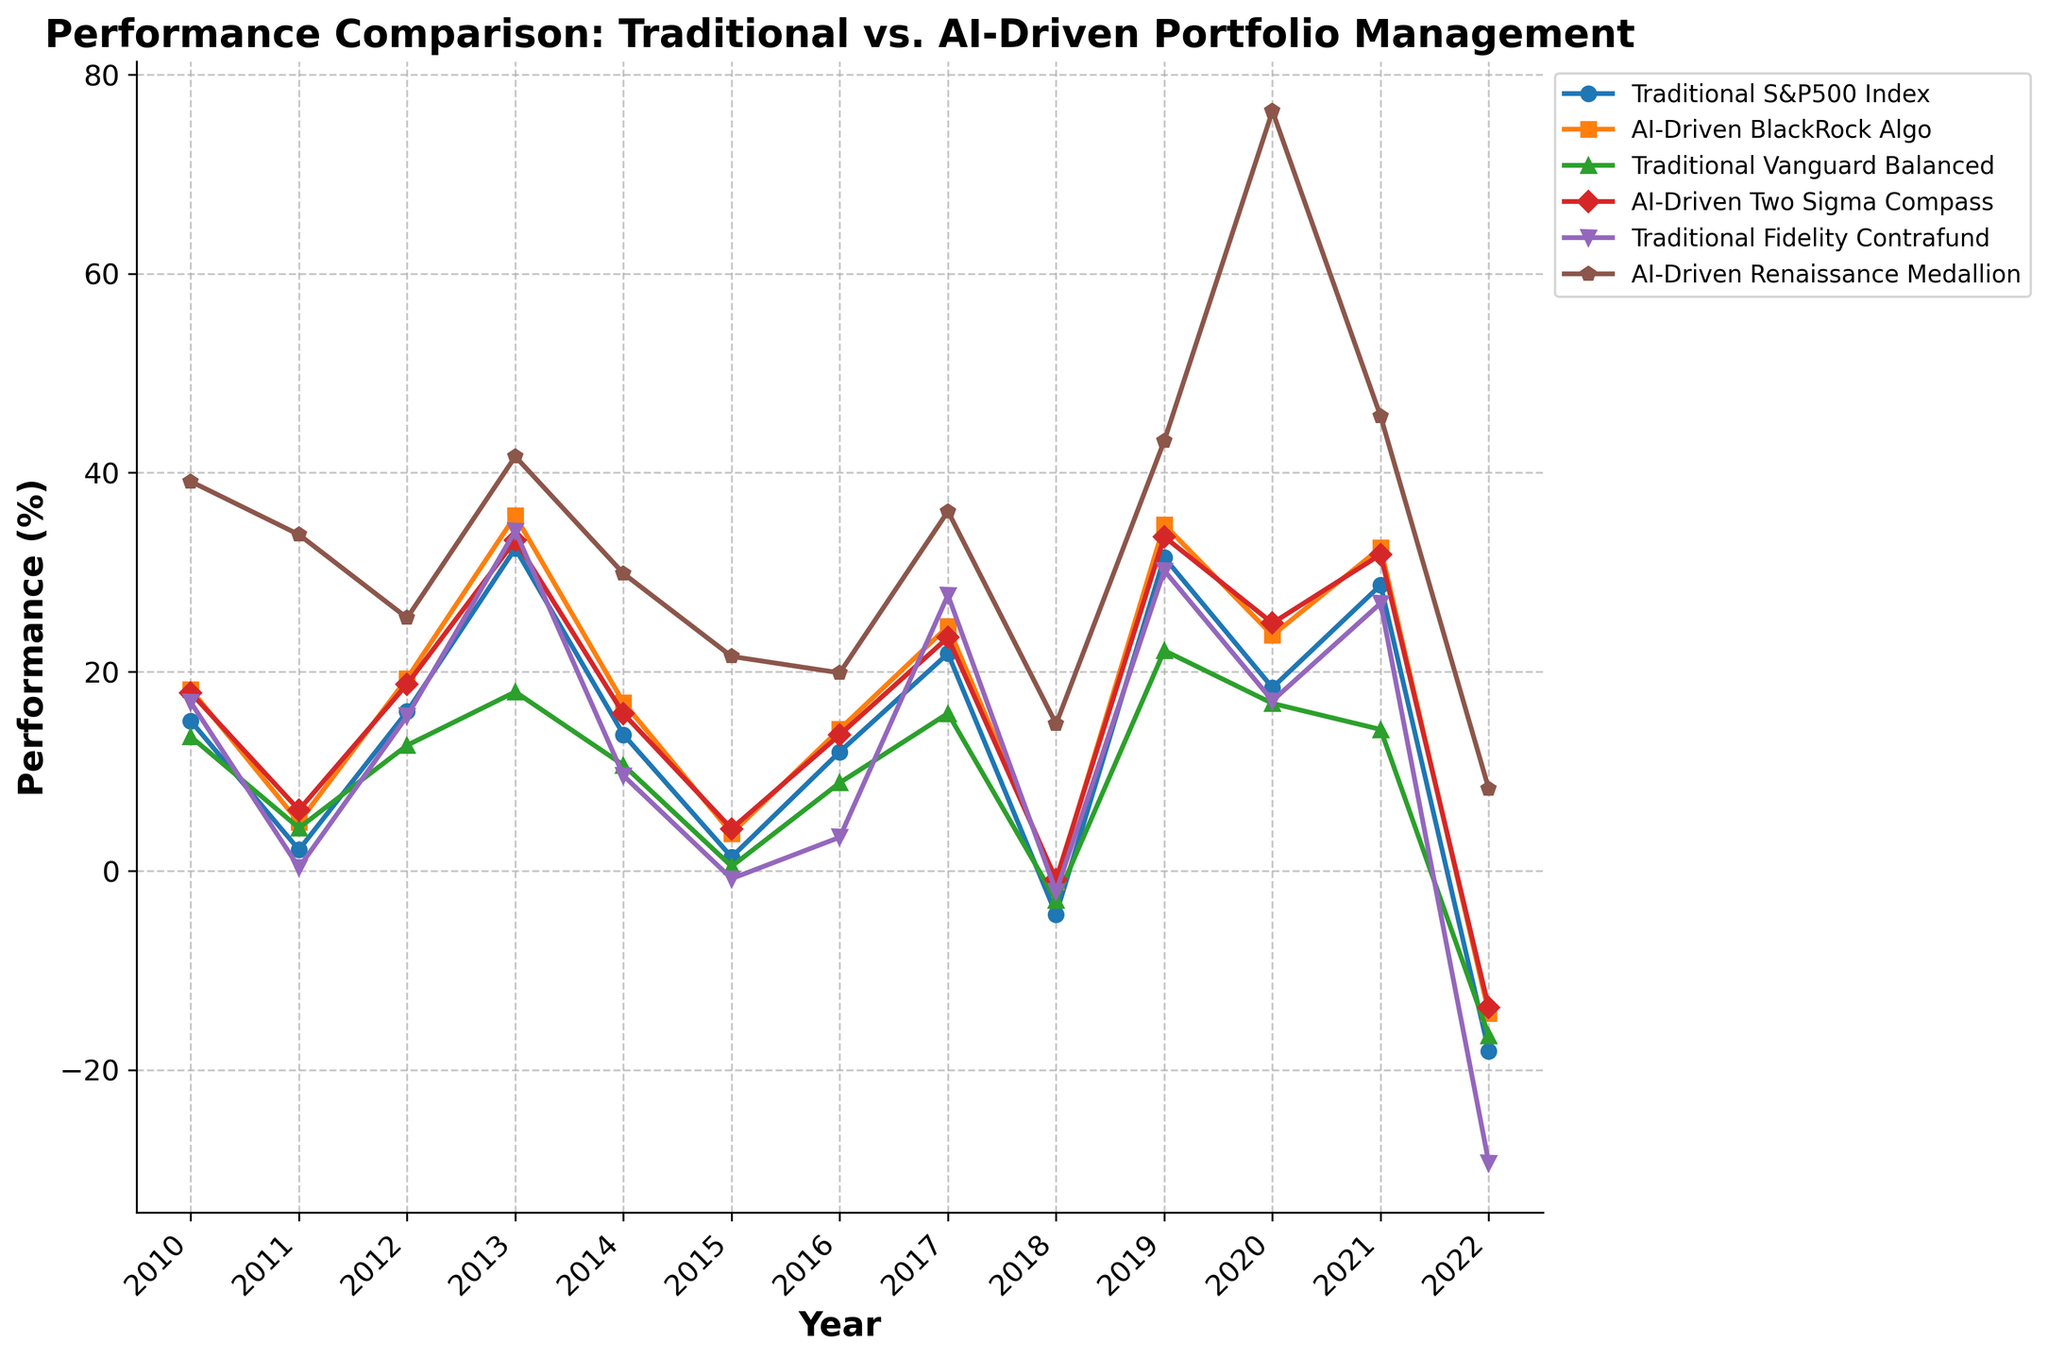Which portfolio management strategy had the highest performance in 2013? Look for the highest peak in the year 2013 among all the lines. The Renaissance Medallion Portfolio appears to have the highest value in 2013.
Answer: Renaissance Medallion Portfolio How did the performance of traditional portfolios compare to AI-driven portfolios in 2020? Compare the heights of the traditional portfolio lines with the AI-driven portfolio lines in 2020. The AI-driven portfolios (BlackRock Algo, Two Sigma Compass, and Renaissance Medallion) outperformed the traditional ones (S&P500 Index, Vanguard Balanced, Fidelity Contrafund).
Answer: AI-driven outperformed What was the difference in performance between the Vanguard Balanced and Two Sigma Compass strategies in 2018? Check the points for Vanguard Balanced and Two Sigma Compass in 2018. Vanguard Balanced is at -2.95% and Two Sigma Compass is at -0.87%. The difference is -0.87% - (-2.95%) = 2.08%.
Answer: 2.08% Which strategy had the most consistent performance over the years? Look for the line with the least fluctuations over the years. The Two Sigma Compass strategy appears to have fewer fluctuations compared to the others.
Answer: Two Sigma Compass In which year did the Fidelity Contrafund strategy underperform the most compared to the S&P500 Index? Compare the yearly performance of Fidelity Contrafund and S&P500 Index. In 2022, Fidelity Contrafund declined by -29.35% and S&P500 Index by -18.11%. The difference here is -29.35% - (-18.11%) = -11.24%. This is the largest negative gap between them.
Answer: 2022 What trend do you observe for the Renaissance Medallion portfolio compared to traditional strategies? Look at the Renaissance Medallion portfolio's line relative to traditional strategies’ lines across all years. The Renaissance Medallion portfolio generally exhibits higher peaks and less severe declines, indicating a more robust performance.
Answer: Outperformed How did the AI-driven portfolios perform during the market decline in 2022? Check the performance values of AI-driven portfolios (BlackRock Algo, Two Sigma Compass, Renaissance Medallion) in 2022. BlackRock Algo fell -14.32%, Two Sigma Compass fell -13.76%, but Renaissance Medallion still grew by 8.23%.
Answer: Mixed performance 